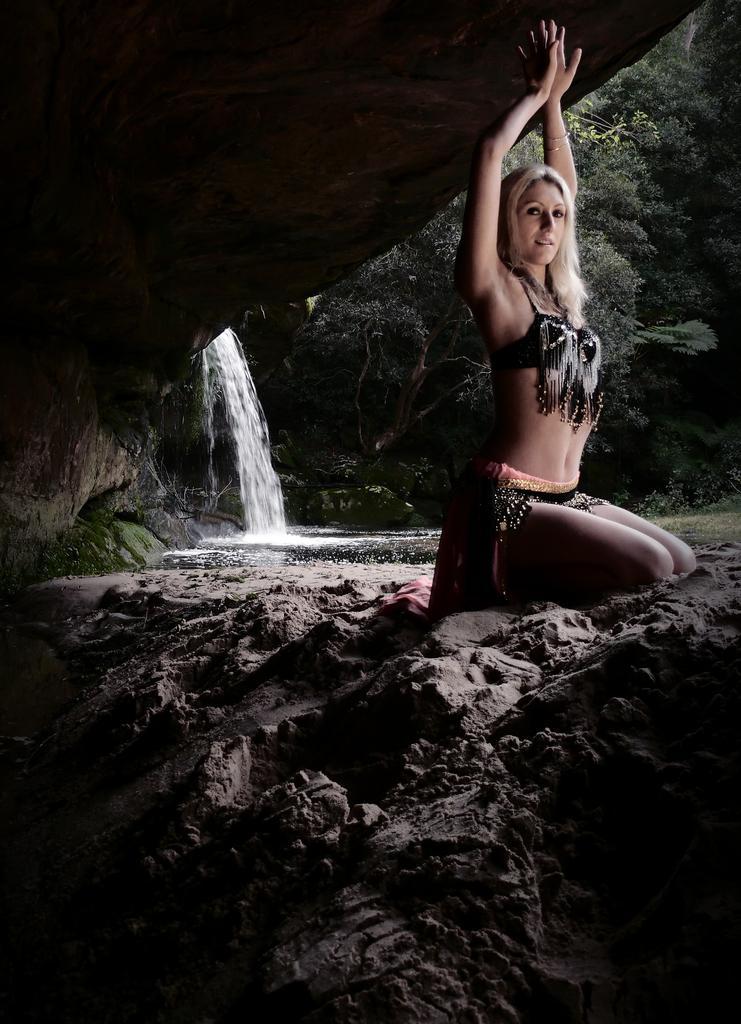How would you summarize this image in a sentence or two? In this image, we can see a person wearing clothes. There is a waterfall on the left side of the image. There are some trees on the right side of the image. 